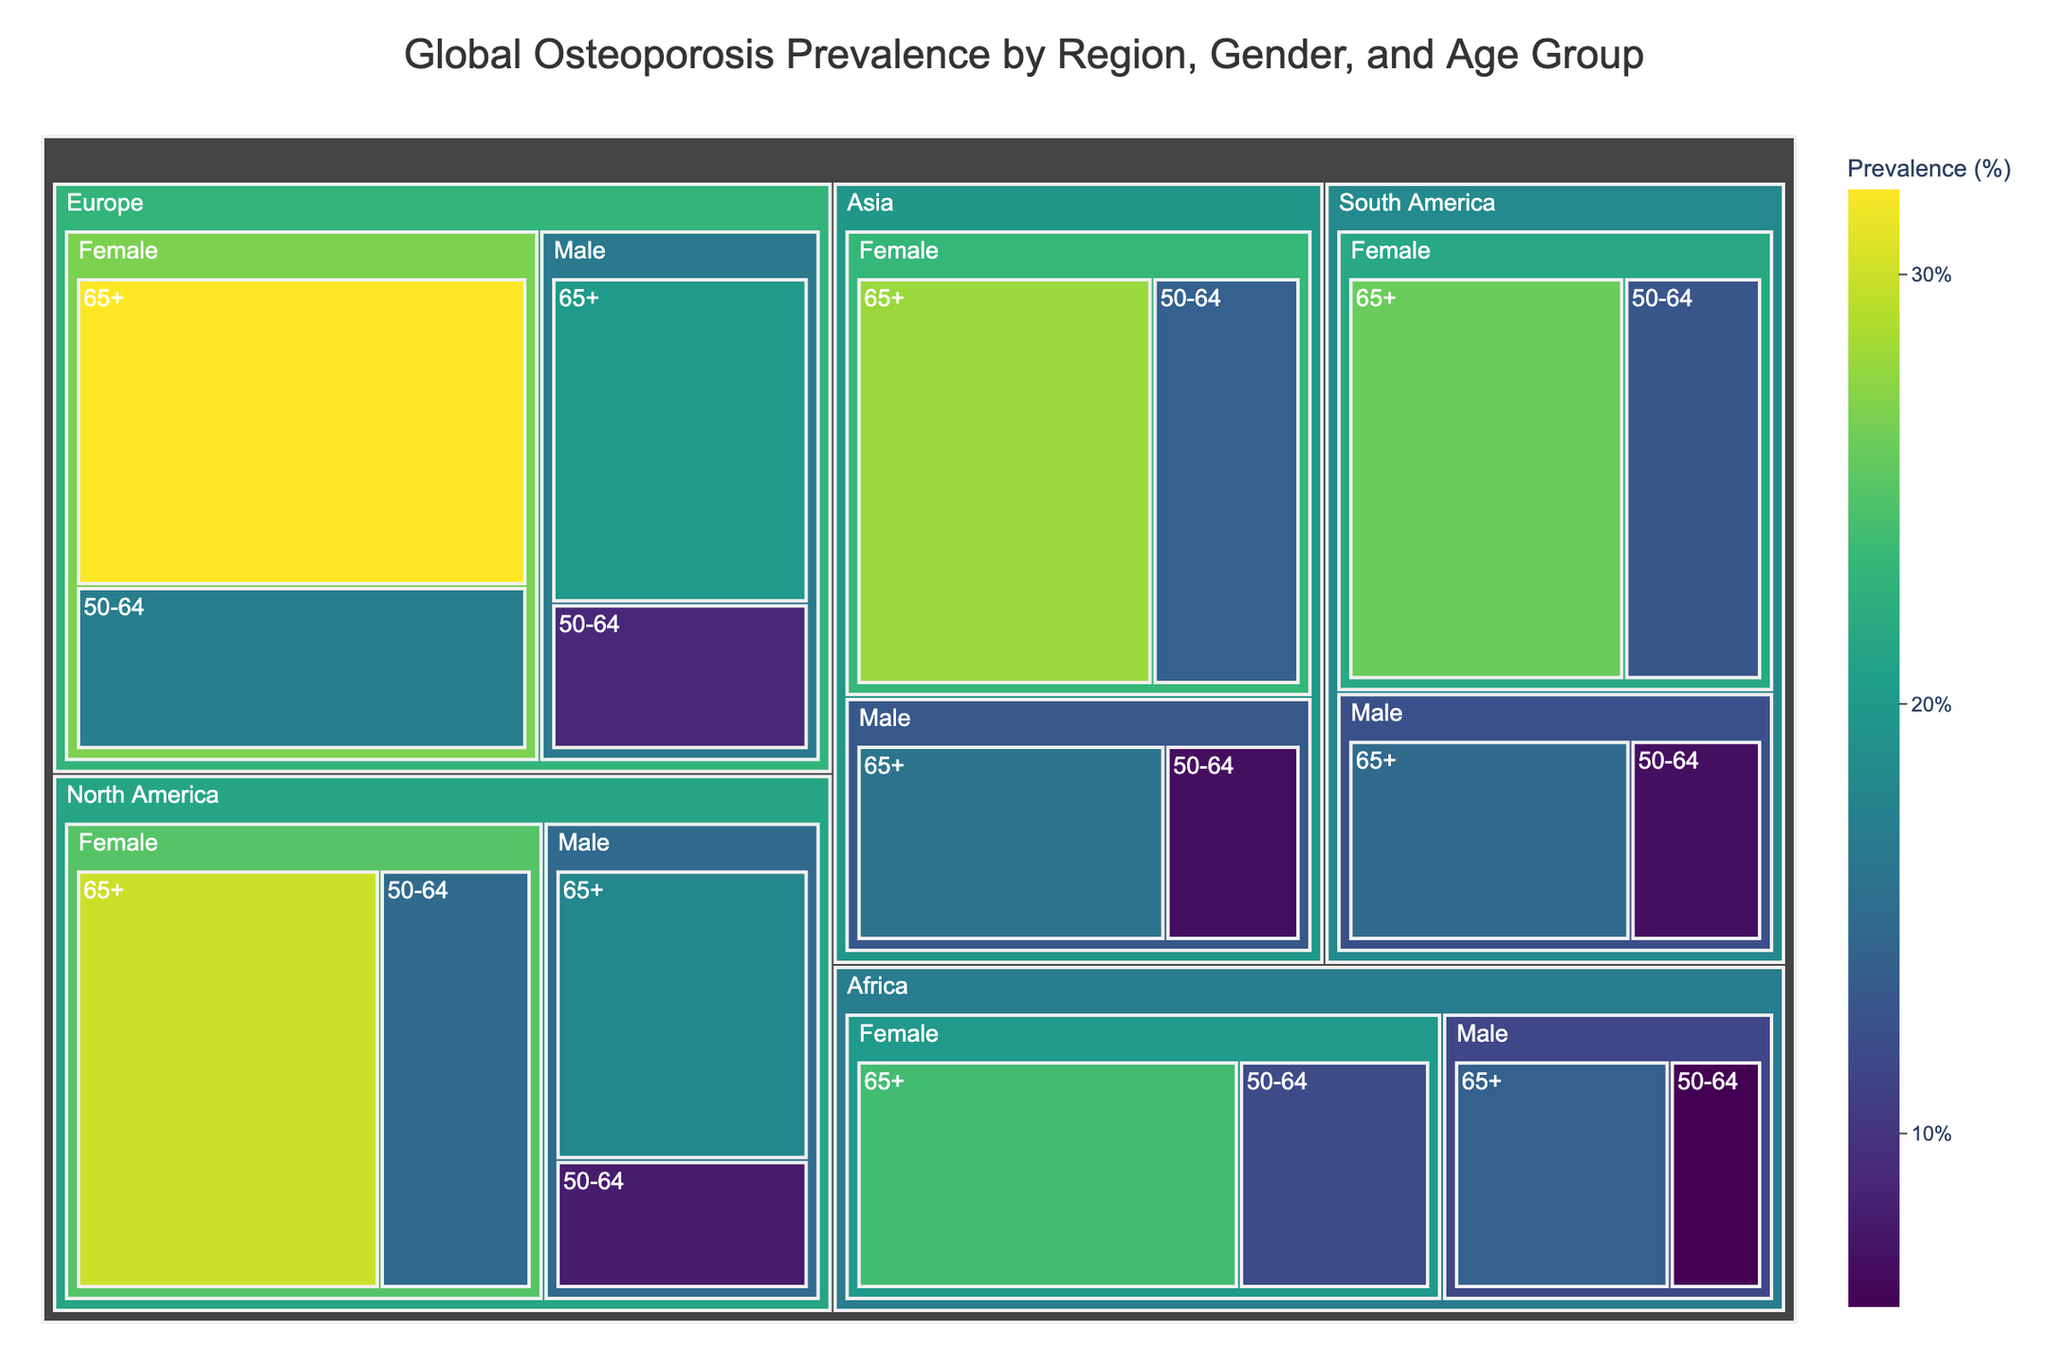What is the title of the treemap? The title of the treemap is written at the top of the plot.
Answer: Global Osteoporosis Prevalence by Region, Gender, and Age Group Which region has the highest osteoporosis prevalence percentage for females aged 65+? The color gradient and prevalence percentage are shown inside each segment of the treemap. By looking for the darkest segment under "Female" and "65+" in different regions, we can identify the highest value.
Answer: Europe Compare the prevalence of osteoporosis in males aged 50-64 between North America and Europe. Which region has a higher value? Look for the sections under "Male" and "50-64" for both North America and Europe and compare the percentages.
Answer: Europe What is the average prevalence of osteoporosis in Asia for females across all age groups? Locate all segments for Asia under "Female," then sum the percentages and divide by the number of segments. (28% + 14%) / 2 = 21%
Answer: 21% How much higher is the prevalence of osteoporosis in North American females aged 65+ compared to North American males aged 65+? Find the percentages for females and males aged 65+ in North America and subtract the smaller value from the larger one. 30% - 18% = 12%
Answer: 12% Which gender has a higher osteoporosis prevalence in Africa for individuals aged 50-64? Check the sections for Africa under "50-64" for both Male and Female and compare the values.
Answer: Female Which geographical region has the lowest prevalence percentage for males aged 50-64? Look through each region for the segment under "Male" and "50-64" and identify the one with the lowest percentage.
Answer: Africa Is the osteoporosis prevalence for females aged 65+ higher in South America or Asia? Compare the percentages for females aged 65+ in South America with those in Asia.
Answer: South America 